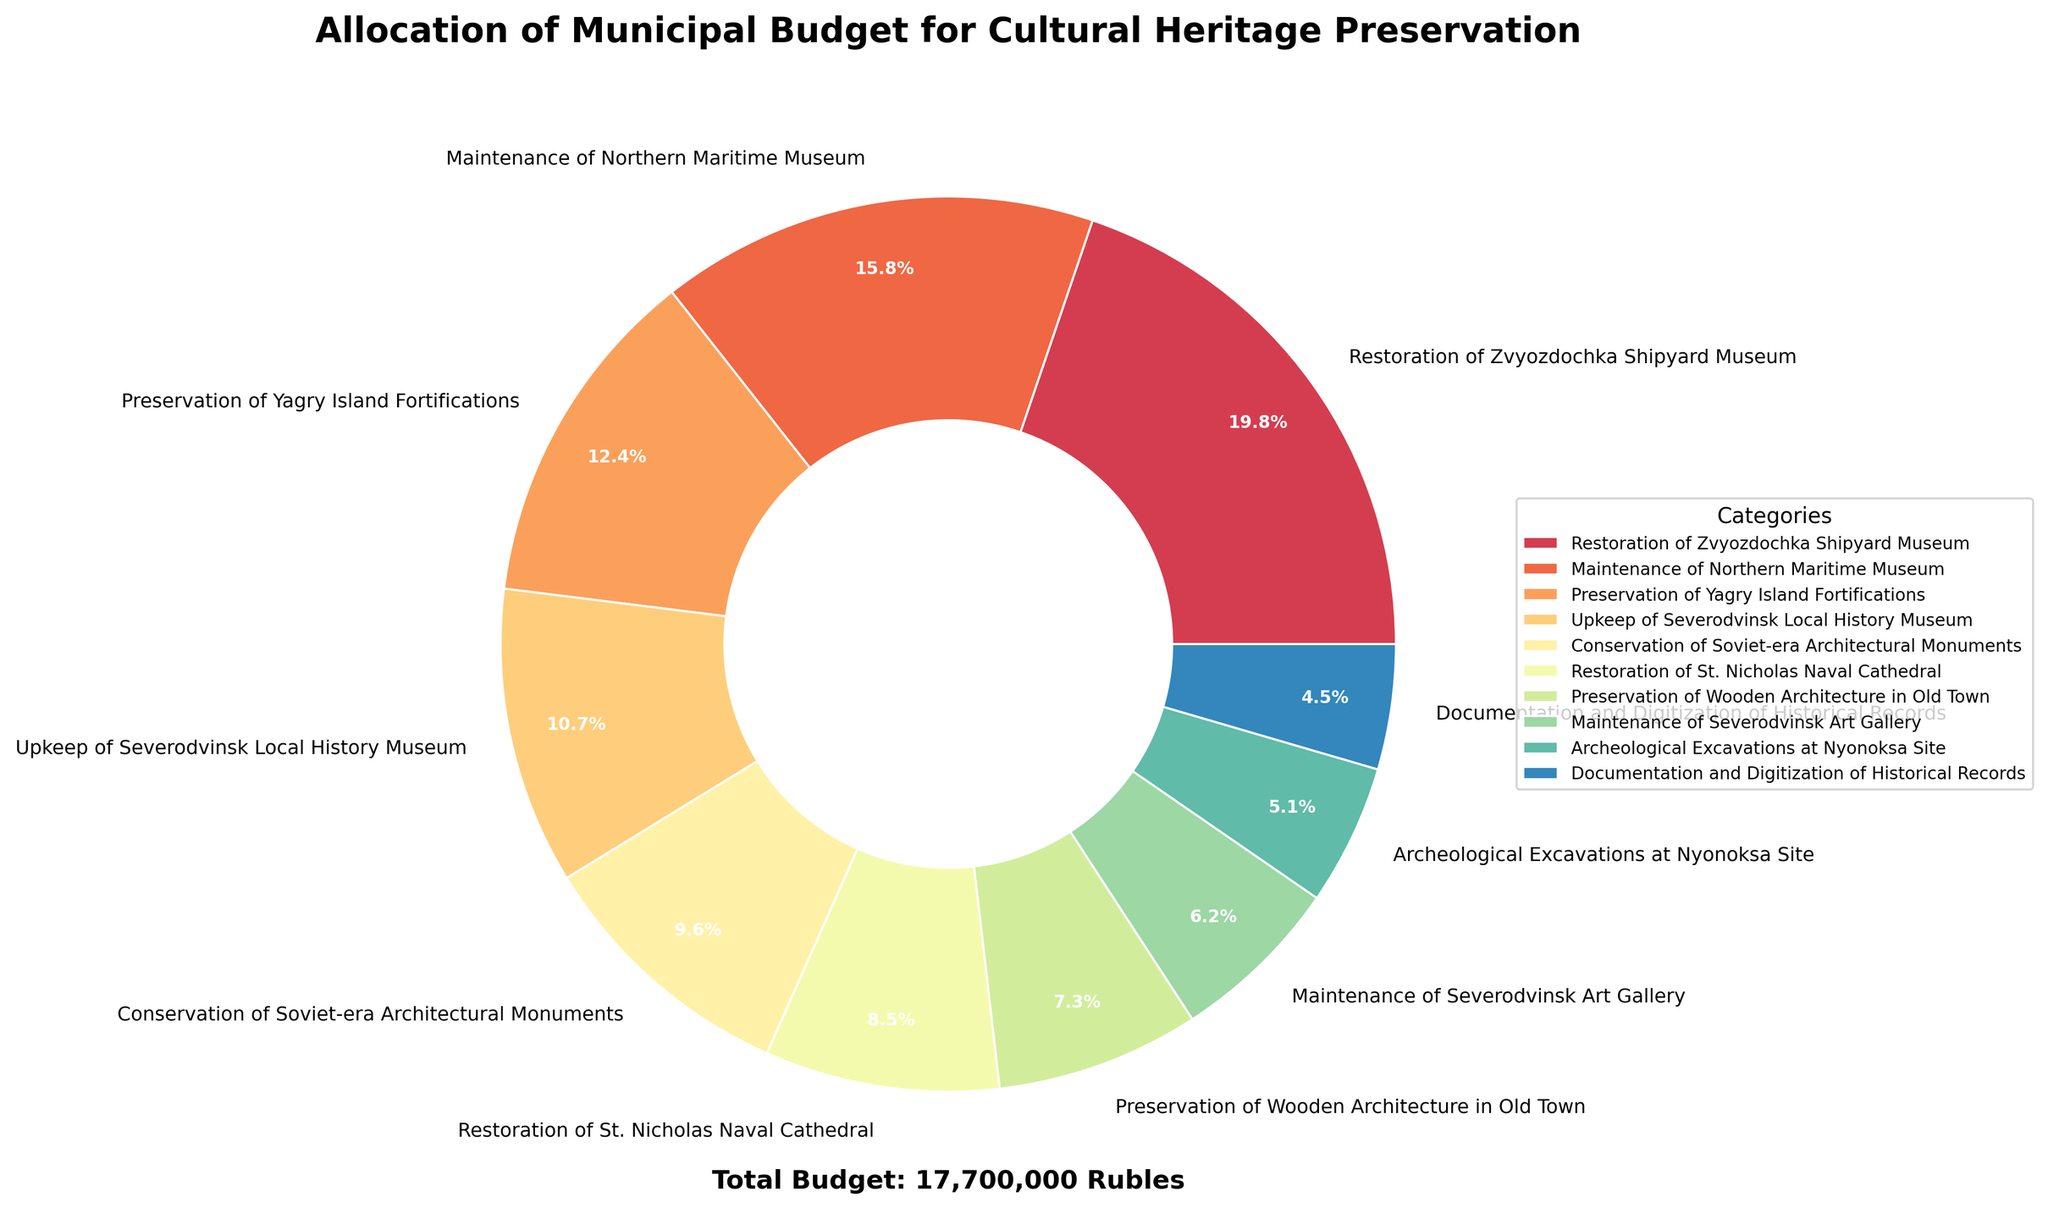Which category received the highest allocation of the municipal budget? The pie chart shows each category's budget allocation in both monetary value and percentage. The largest portion is for the "Restoration of Zvyozdochka Shipyard Museum" with 3,500,000 rubles which corresponds to the biggest slice in the chart.
Answer: Restoration of Zvyozdochka Shipyard Museum Which two categories received the smallest budget allocations, and what are their percentages? By looking at the smallest slices of the pie chart, "Documentation and Digitization of Historical Records" and "Archeological Excavations at Nyonoksa Site" have the smallest allocations. Their percentages are 2.9% and 3.3%, respectively.
Answer: Documentation and Digitization of Historical Records (2.9%), Archeological Excavations at Nyonoksa Site (3.3%) What is the combined budget allocation for the "Conservation of Soviet-era Architectural Monuments" and the "Restoration of St. Nicholas Naval Cathedral"? From the pie chart, we see the specific allocations for these categories: 1,700,000 rubles for "Conservation of Soviet-era Architectural Monuments" and 1,500,000 rubles for the "Restoration of St. Nicholas Naval Cathedral". Adding these values together gives us 3,200,000 rubles.
Answer: 3,200,000 rubles What percentage of the total budget is dedicated to the Maintenance of Northern Maritime Museum? The pie chart directly indicates that the "Maintenance of Northern Maritime Museum" has a budget allocation of 2,800,000 rubles. The chart also indicates this is approximately 18.6% of the total budget.
Answer: 18.6% How does the budget allocated to "Upkeep of Severodvinsk Local History Museum" compare with that of the "Maintenance of Severodvinsk Art Gallery"? The chart shows that "Upkeep of Severodvinsk Local History Museum" is allocated 1,900,000 rubles whereas "Maintenance of Severodvinsk Art Gallery" is allocated 1,100,000 rubles. Therefore, the "Upkeep of Severodvinsk Local History Museum" has 800,000 rubles more than the "Maintenance of Severodvinsk Art Gallery".
Answer: 800,000 rubles more Which category's allocation is the closest to 10% of the total budget? In the pie chart, the "Preservation of Yagry Island Fortifications" shows an allocation of 2,200,000 rubles, which translates to approximately 14.6% of the total budget. This is the closest category to 10%.
Answer: Preservation of Yagry Island Fortifications What is the difference in budget allocation between the highest and lowest-funded projects? From the pie chart, the highest-funded project is the "Restoration of Zvyozdochka Shipyard Museum" with 3,500,000 rubles, and the lowest-funded project is "Documentation and Digitization of Historical Records" with 800,000 rubles. The difference between them is 3,500,000 - 800,000 = 2,700,000 rubles.
Answer: 2,700,000 rubles How many categories have a budget allocation of over 2,000,000 rubles? By visually scanning the pie chart slices, we count the categories with allocations over 2,000,000 rubles: "Restoration of Zvyozdochka Shipyard Museum", "Maintenance of Northern Maritime Museum", and "Preservation of Yagry Island Fortifications". This gives us a total of three categories.
Answer: 3 What is the average budget allocation across all categories? To find the average budget allocation, sum all the given budget values and divide by the number of categories. Summing the allocations gives us 17,400,000 rubles, and there are 10 categories. So, the average budget is 17,400,000 / 10 = 1,740,000 rubles.
Answer: 1,740,000 rubles 